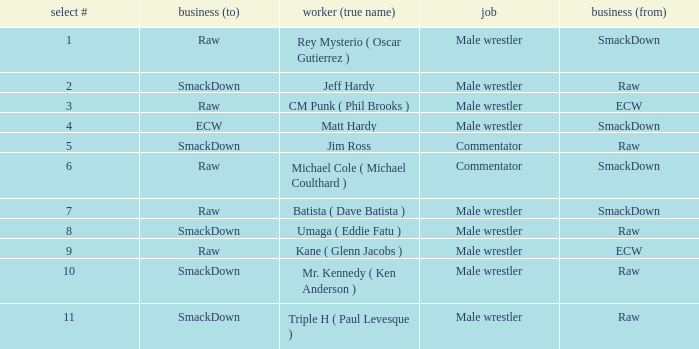Pick # 3 works for which brand? ECW. 